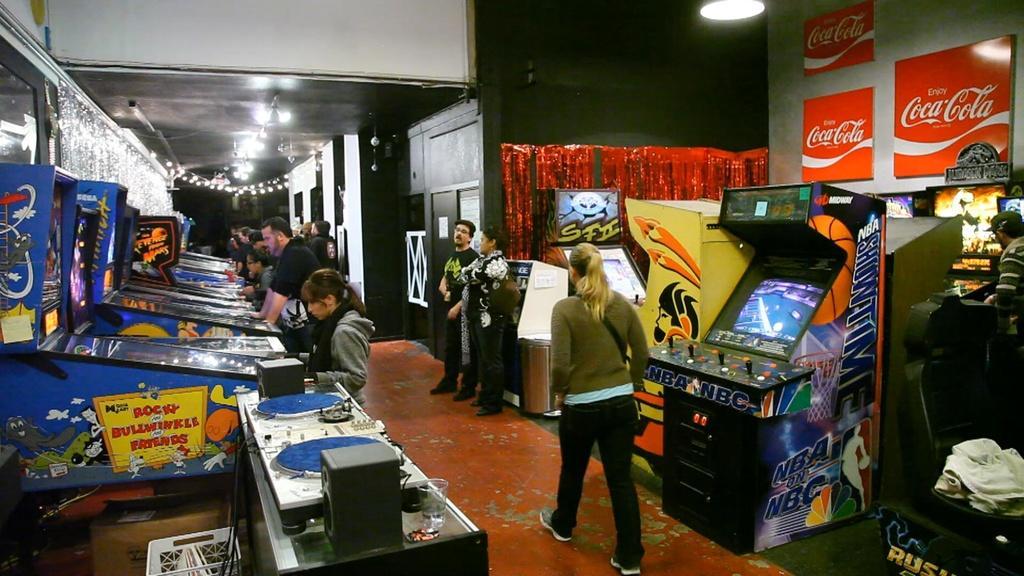How would you summarize this image in a sentence or two? This is the picture of a room. On the left side of the image there are group of people standing at the machine. There is a speaker and glass on the table. On the right side of the image there is a woman walking and there are two persons standing and there is a person standing at the machine and there are machines. At the top there are lights and there are boards on the wall. At the bottom there is a cardboard box. 